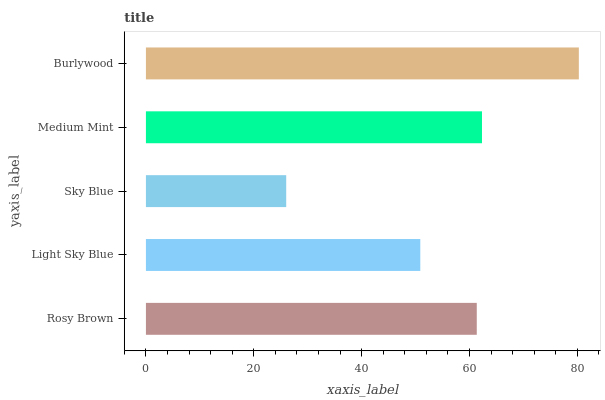Is Sky Blue the minimum?
Answer yes or no. Yes. Is Burlywood the maximum?
Answer yes or no. Yes. Is Light Sky Blue the minimum?
Answer yes or no. No. Is Light Sky Blue the maximum?
Answer yes or no. No. Is Rosy Brown greater than Light Sky Blue?
Answer yes or no. Yes. Is Light Sky Blue less than Rosy Brown?
Answer yes or no. Yes. Is Light Sky Blue greater than Rosy Brown?
Answer yes or no. No. Is Rosy Brown less than Light Sky Blue?
Answer yes or no. No. Is Rosy Brown the high median?
Answer yes or no. Yes. Is Rosy Brown the low median?
Answer yes or no. Yes. Is Medium Mint the high median?
Answer yes or no. No. Is Medium Mint the low median?
Answer yes or no. No. 